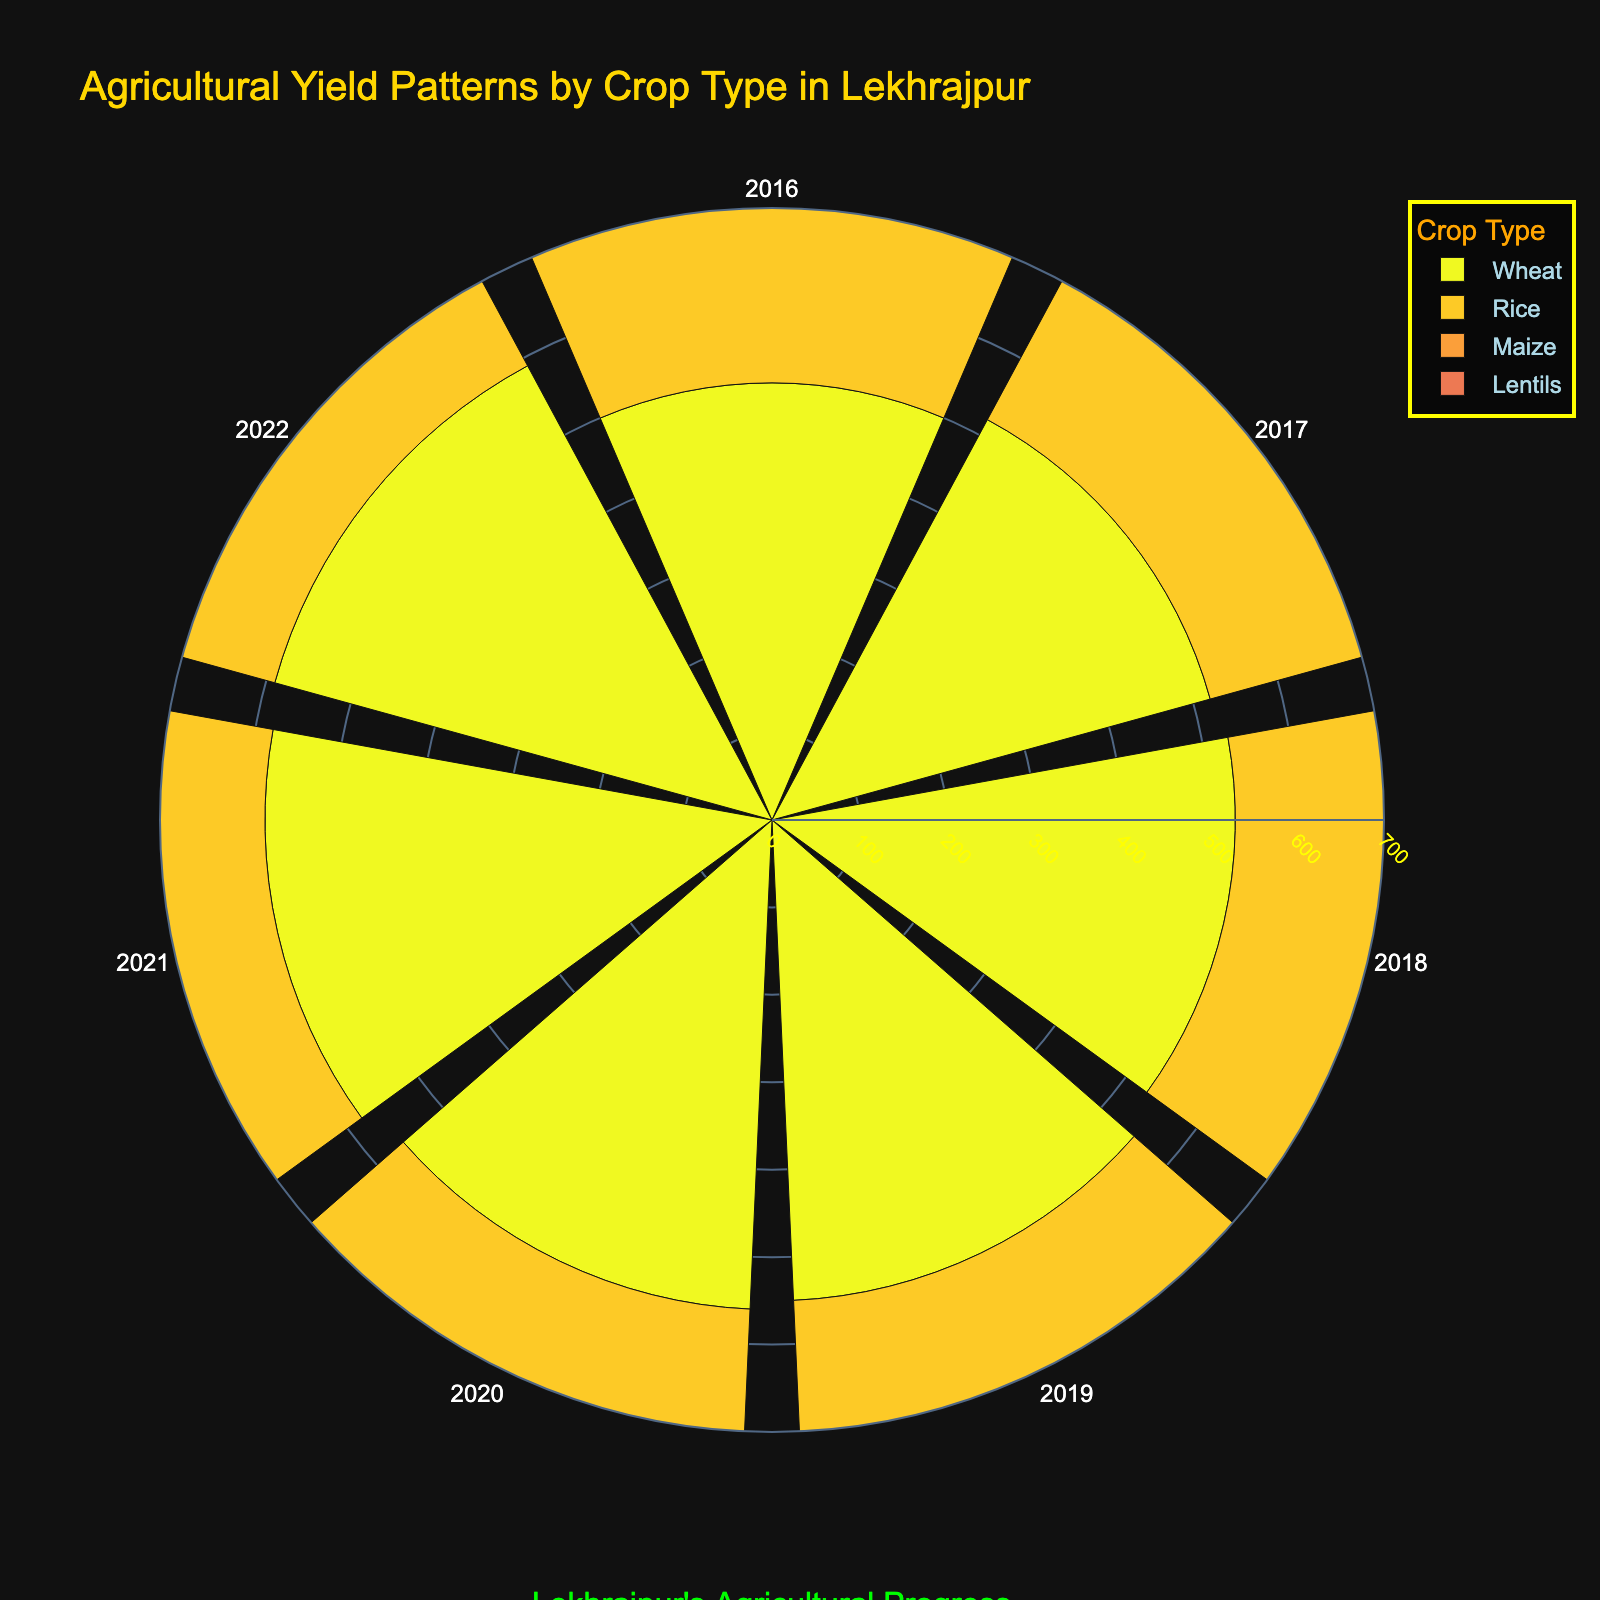How many different crop types are shown in the rose chart? The rose chart uses different colors to represent different crop types. By counting the distinct colors or looking at the legend, we can identify the number of different crop types plotted.
Answer: 4 What is the title of the rose chart? The title of the rose chart is displayed at the top of the figure in a larger and distinctive font size and color.
Answer: Agricultural Yield Patterns by Crop Type in Lekhrajpur Which year shows the highest yield for Rice? Observing each year's radial bar for the Rice segment, the longest bar would indicate the year with the highest yield.
Answer: 2022 Which crop had the most consistent yield pattern across the years? By examining the radial bars for each crop across all years, identify the crop that shows the least variation in bar length from year to year.
Answer: Wheat In which year did Lentils see the largest increase in yield compared to the previous year? Calculate the year-on-year difference in yield for Lentils and identify the year with the maximum positive difference. E.g., (2017: 265 - 2016: 250) = 15, (2019: 290 - 2018: 270) = 20
Answer: 2019 Comparing 2018 and 2019, how much did the yield for Maize increase? The difference in the lengths of the radial bars for Maize between 2018 and 2019 gives the increase in yield. 2019 yield (340) minus 2018 yield (320).
Answer: 20 Which crop had the highest yield in 2016? By observing the radial length for each crop type in 2016, the longest bar indicates the crop with the highest yield.
Answer: Rice How does the 2020 Rice yield compare to the 2017 Rice yield? Compare the lengths of the radial bars for Rice in 2020 and 2017. Check whether the 2020 yield bar is longer or shorter than the 2017 bar.
Answer: Higher What is the aggregate yield of all crops in 2021? Sum up the yield for each crop type in 2021 by adding the lengths of all the corresponding bars. (Wheat: 580, Rice: 650, Maize: 360, Lentils: 315; 580 + 650 + 360 + 315).
Answer: 1905 Which crop type had the fastest yield growth over the six years? Calculate the increase in yield for each crop from 2016 to 2022, then determine which crop had the highest increase. Wheat: 590 - 500 = 90, Rice: 670 - 600 = 70, Maize: 370 - 300 = 70, Lentils: 320 - 250 = 70.
Answer: Wheat 